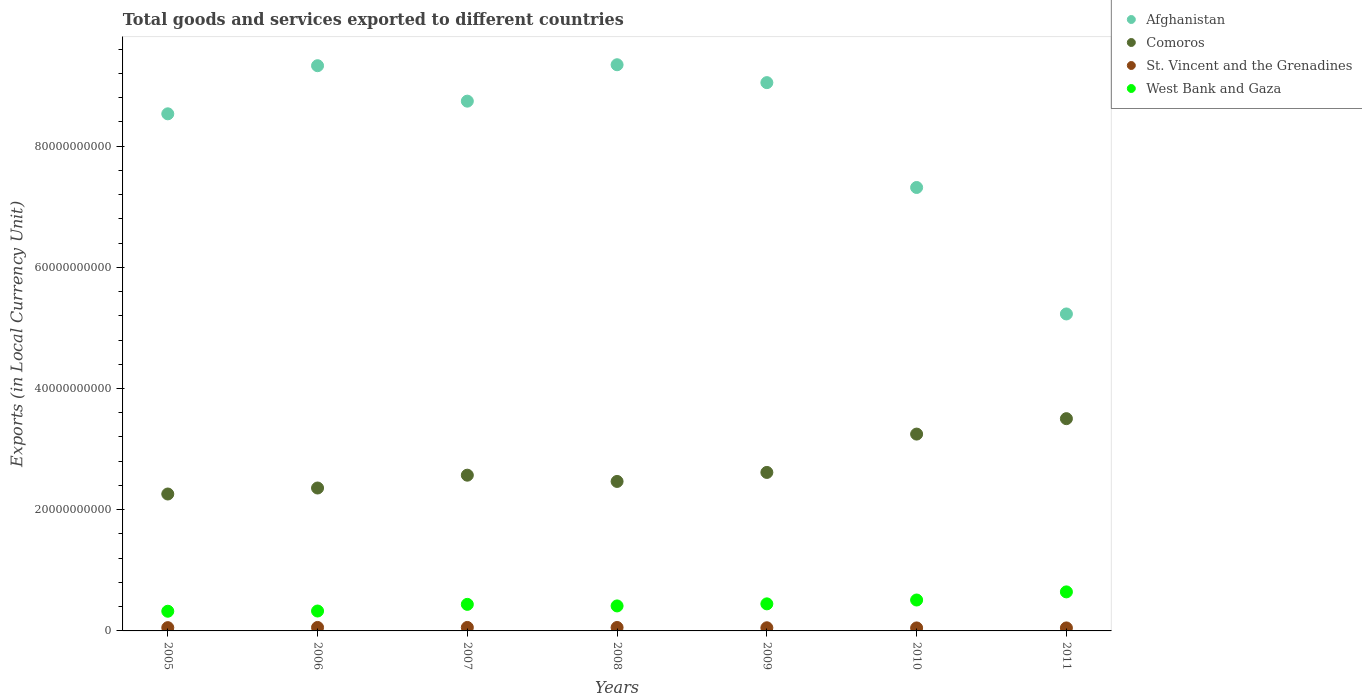What is the Amount of goods and services exports in West Bank and Gaza in 2005?
Provide a succinct answer. 3.25e+09. Across all years, what is the maximum Amount of goods and services exports in West Bank and Gaza?
Offer a terse response. 6.44e+09. Across all years, what is the minimum Amount of goods and services exports in West Bank and Gaza?
Your answer should be compact. 3.25e+09. In which year was the Amount of goods and services exports in Afghanistan maximum?
Offer a very short reply. 2008. In which year was the Amount of goods and services exports in Comoros minimum?
Your answer should be compact. 2005. What is the total Amount of goods and services exports in St. Vincent and the Grenadines in the graph?
Ensure brevity in your answer.  3.76e+09. What is the difference between the Amount of goods and services exports in West Bank and Gaza in 2009 and that in 2011?
Your response must be concise. -1.98e+09. What is the difference between the Amount of goods and services exports in Afghanistan in 2006 and the Amount of goods and services exports in St. Vincent and the Grenadines in 2007?
Make the answer very short. 9.27e+1. What is the average Amount of goods and services exports in Comoros per year?
Provide a succinct answer. 2.72e+1. In the year 2006, what is the difference between the Amount of goods and services exports in West Bank and Gaza and Amount of goods and services exports in St. Vincent and the Grenadines?
Make the answer very short. 2.71e+09. In how many years, is the Amount of goods and services exports in St. Vincent and the Grenadines greater than 48000000000 LCU?
Keep it short and to the point. 0. What is the ratio of the Amount of goods and services exports in West Bank and Gaza in 2006 to that in 2008?
Provide a succinct answer. 0.8. Is the Amount of goods and services exports in Comoros in 2006 less than that in 2011?
Offer a terse response. Yes. Is the difference between the Amount of goods and services exports in West Bank and Gaza in 2008 and 2010 greater than the difference between the Amount of goods and services exports in St. Vincent and the Grenadines in 2008 and 2010?
Your answer should be very brief. No. What is the difference between the highest and the second highest Amount of goods and services exports in St. Vincent and the Grenadines?
Offer a terse response. 6.09e+05. What is the difference between the highest and the lowest Amount of goods and services exports in Comoros?
Provide a succinct answer. 1.24e+1. Is it the case that in every year, the sum of the Amount of goods and services exports in Comoros and Amount of goods and services exports in Afghanistan  is greater than the Amount of goods and services exports in St. Vincent and the Grenadines?
Ensure brevity in your answer.  Yes. Does the Amount of goods and services exports in Comoros monotonically increase over the years?
Your answer should be very brief. No. Is the Amount of goods and services exports in St. Vincent and the Grenadines strictly less than the Amount of goods and services exports in West Bank and Gaza over the years?
Keep it short and to the point. Yes. How many dotlines are there?
Offer a very short reply. 4. How many years are there in the graph?
Provide a succinct answer. 7. What is the difference between two consecutive major ticks on the Y-axis?
Keep it short and to the point. 2.00e+1. Does the graph contain any zero values?
Offer a very short reply. No. Where does the legend appear in the graph?
Make the answer very short. Top right. How many legend labels are there?
Your answer should be compact. 4. What is the title of the graph?
Make the answer very short. Total goods and services exported to different countries. Does "Ethiopia" appear as one of the legend labels in the graph?
Keep it short and to the point. No. What is the label or title of the X-axis?
Ensure brevity in your answer.  Years. What is the label or title of the Y-axis?
Provide a succinct answer. Exports (in Local Currency Unit). What is the Exports (in Local Currency Unit) of Afghanistan in 2005?
Your answer should be compact. 8.53e+1. What is the Exports (in Local Currency Unit) of Comoros in 2005?
Keep it short and to the point. 2.26e+1. What is the Exports (in Local Currency Unit) in St. Vincent and the Grenadines in 2005?
Give a very brief answer. 5.41e+08. What is the Exports (in Local Currency Unit) of West Bank and Gaza in 2005?
Your response must be concise. 3.25e+09. What is the Exports (in Local Currency Unit) of Afghanistan in 2006?
Make the answer very short. 9.33e+1. What is the Exports (in Local Currency Unit) of Comoros in 2006?
Your answer should be very brief. 2.36e+1. What is the Exports (in Local Currency Unit) of St. Vincent and the Grenadines in 2006?
Offer a very short reply. 5.72e+08. What is the Exports (in Local Currency Unit) in West Bank and Gaza in 2006?
Your response must be concise. 3.28e+09. What is the Exports (in Local Currency Unit) in Afghanistan in 2007?
Give a very brief answer. 8.74e+1. What is the Exports (in Local Currency Unit) of Comoros in 2007?
Offer a terse response. 2.57e+1. What is the Exports (in Local Currency Unit) in St. Vincent and the Grenadines in 2007?
Provide a succinct answer. 5.73e+08. What is the Exports (in Local Currency Unit) of West Bank and Gaza in 2007?
Provide a succinct answer. 4.38e+09. What is the Exports (in Local Currency Unit) of Afghanistan in 2008?
Make the answer very short. 9.34e+1. What is the Exports (in Local Currency Unit) of Comoros in 2008?
Your answer should be very brief. 2.47e+1. What is the Exports (in Local Currency Unit) of St. Vincent and the Grenadines in 2008?
Make the answer very short. 5.67e+08. What is the Exports (in Local Currency Unit) of West Bank and Gaza in 2008?
Your answer should be very brief. 4.12e+09. What is the Exports (in Local Currency Unit) in Afghanistan in 2009?
Your answer should be compact. 9.05e+1. What is the Exports (in Local Currency Unit) of Comoros in 2009?
Keep it short and to the point. 2.62e+1. What is the Exports (in Local Currency Unit) in St. Vincent and the Grenadines in 2009?
Provide a short and direct response. 5.19e+08. What is the Exports (in Local Currency Unit) of West Bank and Gaza in 2009?
Offer a terse response. 4.47e+09. What is the Exports (in Local Currency Unit) of Afghanistan in 2010?
Provide a short and direct response. 7.32e+1. What is the Exports (in Local Currency Unit) in Comoros in 2010?
Keep it short and to the point. 3.25e+1. What is the Exports (in Local Currency Unit) in St. Vincent and the Grenadines in 2010?
Give a very brief answer. 4.95e+08. What is the Exports (in Local Currency Unit) of West Bank and Gaza in 2010?
Ensure brevity in your answer.  5.10e+09. What is the Exports (in Local Currency Unit) in Afghanistan in 2011?
Offer a terse response. 5.23e+1. What is the Exports (in Local Currency Unit) in Comoros in 2011?
Provide a succinct answer. 3.50e+1. What is the Exports (in Local Currency Unit) in St. Vincent and the Grenadines in 2011?
Offer a very short reply. 4.94e+08. What is the Exports (in Local Currency Unit) of West Bank and Gaza in 2011?
Provide a short and direct response. 6.44e+09. Across all years, what is the maximum Exports (in Local Currency Unit) of Afghanistan?
Make the answer very short. 9.34e+1. Across all years, what is the maximum Exports (in Local Currency Unit) of Comoros?
Ensure brevity in your answer.  3.50e+1. Across all years, what is the maximum Exports (in Local Currency Unit) of St. Vincent and the Grenadines?
Your answer should be very brief. 5.73e+08. Across all years, what is the maximum Exports (in Local Currency Unit) of West Bank and Gaza?
Keep it short and to the point. 6.44e+09. Across all years, what is the minimum Exports (in Local Currency Unit) in Afghanistan?
Your response must be concise. 5.23e+1. Across all years, what is the minimum Exports (in Local Currency Unit) in Comoros?
Your response must be concise. 2.26e+1. Across all years, what is the minimum Exports (in Local Currency Unit) of St. Vincent and the Grenadines?
Your answer should be very brief. 4.94e+08. Across all years, what is the minimum Exports (in Local Currency Unit) of West Bank and Gaza?
Make the answer very short. 3.25e+09. What is the total Exports (in Local Currency Unit) in Afghanistan in the graph?
Provide a succinct answer. 5.75e+11. What is the total Exports (in Local Currency Unit) of Comoros in the graph?
Make the answer very short. 1.90e+11. What is the total Exports (in Local Currency Unit) in St. Vincent and the Grenadines in the graph?
Offer a very short reply. 3.76e+09. What is the total Exports (in Local Currency Unit) of West Bank and Gaza in the graph?
Give a very brief answer. 3.10e+1. What is the difference between the Exports (in Local Currency Unit) of Afghanistan in 2005 and that in 2006?
Provide a short and direct response. -7.94e+09. What is the difference between the Exports (in Local Currency Unit) in Comoros in 2005 and that in 2006?
Offer a very short reply. -9.89e+08. What is the difference between the Exports (in Local Currency Unit) in St. Vincent and the Grenadines in 2005 and that in 2006?
Offer a terse response. -3.09e+07. What is the difference between the Exports (in Local Currency Unit) of West Bank and Gaza in 2005 and that in 2006?
Provide a short and direct response. -3.63e+07. What is the difference between the Exports (in Local Currency Unit) in Afghanistan in 2005 and that in 2007?
Your response must be concise. -2.09e+09. What is the difference between the Exports (in Local Currency Unit) of Comoros in 2005 and that in 2007?
Give a very brief answer. -3.11e+09. What is the difference between the Exports (in Local Currency Unit) of St. Vincent and the Grenadines in 2005 and that in 2007?
Keep it short and to the point. -3.15e+07. What is the difference between the Exports (in Local Currency Unit) in West Bank and Gaza in 2005 and that in 2007?
Make the answer very short. -1.13e+09. What is the difference between the Exports (in Local Currency Unit) of Afghanistan in 2005 and that in 2008?
Ensure brevity in your answer.  -8.10e+09. What is the difference between the Exports (in Local Currency Unit) of Comoros in 2005 and that in 2008?
Provide a short and direct response. -2.07e+09. What is the difference between the Exports (in Local Currency Unit) in St. Vincent and the Grenadines in 2005 and that in 2008?
Your answer should be very brief. -2.60e+07. What is the difference between the Exports (in Local Currency Unit) of West Bank and Gaza in 2005 and that in 2008?
Your response must be concise. -8.76e+08. What is the difference between the Exports (in Local Currency Unit) in Afghanistan in 2005 and that in 2009?
Make the answer very short. -5.15e+09. What is the difference between the Exports (in Local Currency Unit) of Comoros in 2005 and that in 2009?
Offer a very short reply. -3.56e+09. What is the difference between the Exports (in Local Currency Unit) in St. Vincent and the Grenadines in 2005 and that in 2009?
Offer a terse response. 2.22e+07. What is the difference between the Exports (in Local Currency Unit) of West Bank and Gaza in 2005 and that in 2009?
Provide a short and direct response. -1.22e+09. What is the difference between the Exports (in Local Currency Unit) in Afghanistan in 2005 and that in 2010?
Provide a short and direct response. 1.22e+1. What is the difference between the Exports (in Local Currency Unit) of Comoros in 2005 and that in 2010?
Your response must be concise. -9.89e+09. What is the difference between the Exports (in Local Currency Unit) of St. Vincent and the Grenadines in 2005 and that in 2010?
Keep it short and to the point. 4.69e+07. What is the difference between the Exports (in Local Currency Unit) of West Bank and Gaza in 2005 and that in 2010?
Your answer should be very brief. -1.85e+09. What is the difference between the Exports (in Local Currency Unit) of Afghanistan in 2005 and that in 2011?
Offer a very short reply. 3.30e+1. What is the difference between the Exports (in Local Currency Unit) in Comoros in 2005 and that in 2011?
Provide a short and direct response. -1.24e+1. What is the difference between the Exports (in Local Currency Unit) of St. Vincent and the Grenadines in 2005 and that in 2011?
Offer a very short reply. 4.79e+07. What is the difference between the Exports (in Local Currency Unit) in West Bank and Gaza in 2005 and that in 2011?
Make the answer very short. -3.19e+09. What is the difference between the Exports (in Local Currency Unit) in Afghanistan in 2006 and that in 2007?
Keep it short and to the point. 5.85e+09. What is the difference between the Exports (in Local Currency Unit) of Comoros in 2006 and that in 2007?
Provide a succinct answer. -2.12e+09. What is the difference between the Exports (in Local Currency Unit) of St. Vincent and the Grenadines in 2006 and that in 2007?
Provide a short and direct response. -6.09e+05. What is the difference between the Exports (in Local Currency Unit) of West Bank and Gaza in 2006 and that in 2007?
Make the answer very short. -1.10e+09. What is the difference between the Exports (in Local Currency Unit) in Afghanistan in 2006 and that in 2008?
Provide a succinct answer. -1.60e+08. What is the difference between the Exports (in Local Currency Unit) of Comoros in 2006 and that in 2008?
Your response must be concise. -1.08e+09. What is the difference between the Exports (in Local Currency Unit) of St. Vincent and the Grenadines in 2006 and that in 2008?
Provide a short and direct response. 4.93e+06. What is the difference between the Exports (in Local Currency Unit) in West Bank and Gaza in 2006 and that in 2008?
Your answer should be compact. -8.40e+08. What is the difference between the Exports (in Local Currency Unit) in Afghanistan in 2006 and that in 2009?
Provide a succinct answer. 2.79e+09. What is the difference between the Exports (in Local Currency Unit) of Comoros in 2006 and that in 2009?
Offer a very short reply. -2.57e+09. What is the difference between the Exports (in Local Currency Unit) in St. Vincent and the Grenadines in 2006 and that in 2009?
Give a very brief answer. 5.32e+07. What is the difference between the Exports (in Local Currency Unit) in West Bank and Gaza in 2006 and that in 2009?
Make the answer very short. -1.18e+09. What is the difference between the Exports (in Local Currency Unit) in Afghanistan in 2006 and that in 2010?
Provide a succinct answer. 2.01e+1. What is the difference between the Exports (in Local Currency Unit) in Comoros in 2006 and that in 2010?
Your answer should be very brief. -8.90e+09. What is the difference between the Exports (in Local Currency Unit) of St. Vincent and the Grenadines in 2006 and that in 2010?
Give a very brief answer. 7.78e+07. What is the difference between the Exports (in Local Currency Unit) of West Bank and Gaza in 2006 and that in 2010?
Provide a short and direct response. -1.82e+09. What is the difference between the Exports (in Local Currency Unit) of Afghanistan in 2006 and that in 2011?
Ensure brevity in your answer.  4.10e+1. What is the difference between the Exports (in Local Currency Unit) of Comoros in 2006 and that in 2011?
Offer a very short reply. -1.14e+1. What is the difference between the Exports (in Local Currency Unit) in St. Vincent and the Grenadines in 2006 and that in 2011?
Give a very brief answer. 7.88e+07. What is the difference between the Exports (in Local Currency Unit) of West Bank and Gaza in 2006 and that in 2011?
Provide a succinct answer. -3.16e+09. What is the difference between the Exports (in Local Currency Unit) in Afghanistan in 2007 and that in 2008?
Provide a succinct answer. -6.01e+09. What is the difference between the Exports (in Local Currency Unit) of Comoros in 2007 and that in 2008?
Provide a short and direct response. 1.03e+09. What is the difference between the Exports (in Local Currency Unit) of St. Vincent and the Grenadines in 2007 and that in 2008?
Your response must be concise. 5.54e+06. What is the difference between the Exports (in Local Currency Unit) of West Bank and Gaza in 2007 and that in 2008?
Provide a succinct answer. 2.58e+08. What is the difference between the Exports (in Local Currency Unit) of Afghanistan in 2007 and that in 2009?
Your response must be concise. -3.06e+09. What is the difference between the Exports (in Local Currency Unit) in Comoros in 2007 and that in 2009?
Provide a succinct answer. -4.55e+08. What is the difference between the Exports (in Local Currency Unit) of St. Vincent and the Grenadines in 2007 and that in 2009?
Ensure brevity in your answer.  5.38e+07. What is the difference between the Exports (in Local Currency Unit) in West Bank and Gaza in 2007 and that in 2009?
Keep it short and to the point. -8.27e+07. What is the difference between the Exports (in Local Currency Unit) in Afghanistan in 2007 and that in 2010?
Offer a very short reply. 1.42e+1. What is the difference between the Exports (in Local Currency Unit) of Comoros in 2007 and that in 2010?
Your answer should be very brief. -6.78e+09. What is the difference between the Exports (in Local Currency Unit) of St. Vincent and the Grenadines in 2007 and that in 2010?
Provide a succinct answer. 7.84e+07. What is the difference between the Exports (in Local Currency Unit) of West Bank and Gaza in 2007 and that in 2010?
Keep it short and to the point. -7.18e+08. What is the difference between the Exports (in Local Currency Unit) in Afghanistan in 2007 and that in 2011?
Offer a terse response. 3.51e+1. What is the difference between the Exports (in Local Currency Unit) in Comoros in 2007 and that in 2011?
Ensure brevity in your answer.  -9.33e+09. What is the difference between the Exports (in Local Currency Unit) in St. Vincent and the Grenadines in 2007 and that in 2011?
Your answer should be compact. 7.95e+07. What is the difference between the Exports (in Local Currency Unit) of West Bank and Gaza in 2007 and that in 2011?
Provide a short and direct response. -2.06e+09. What is the difference between the Exports (in Local Currency Unit) of Afghanistan in 2008 and that in 2009?
Your answer should be compact. 2.95e+09. What is the difference between the Exports (in Local Currency Unit) of Comoros in 2008 and that in 2009?
Offer a very short reply. -1.49e+09. What is the difference between the Exports (in Local Currency Unit) in St. Vincent and the Grenadines in 2008 and that in 2009?
Offer a very short reply. 4.82e+07. What is the difference between the Exports (in Local Currency Unit) of West Bank and Gaza in 2008 and that in 2009?
Ensure brevity in your answer.  -3.41e+08. What is the difference between the Exports (in Local Currency Unit) of Afghanistan in 2008 and that in 2010?
Provide a succinct answer. 2.03e+1. What is the difference between the Exports (in Local Currency Unit) in Comoros in 2008 and that in 2010?
Give a very brief answer. -7.81e+09. What is the difference between the Exports (in Local Currency Unit) of St. Vincent and the Grenadines in 2008 and that in 2010?
Give a very brief answer. 7.29e+07. What is the difference between the Exports (in Local Currency Unit) of West Bank and Gaza in 2008 and that in 2010?
Keep it short and to the point. -9.76e+08. What is the difference between the Exports (in Local Currency Unit) of Afghanistan in 2008 and that in 2011?
Keep it short and to the point. 4.11e+1. What is the difference between the Exports (in Local Currency Unit) of Comoros in 2008 and that in 2011?
Offer a terse response. -1.04e+1. What is the difference between the Exports (in Local Currency Unit) in St. Vincent and the Grenadines in 2008 and that in 2011?
Provide a succinct answer. 7.39e+07. What is the difference between the Exports (in Local Currency Unit) of West Bank and Gaza in 2008 and that in 2011?
Offer a very short reply. -2.32e+09. What is the difference between the Exports (in Local Currency Unit) in Afghanistan in 2009 and that in 2010?
Keep it short and to the point. 1.73e+1. What is the difference between the Exports (in Local Currency Unit) of Comoros in 2009 and that in 2010?
Your answer should be compact. -6.33e+09. What is the difference between the Exports (in Local Currency Unit) in St. Vincent and the Grenadines in 2009 and that in 2010?
Offer a very short reply. 2.46e+07. What is the difference between the Exports (in Local Currency Unit) in West Bank and Gaza in 2009 and that in 2010?
Provide a succinct answer. -6.35e+08. What is the difference between the Exports (in Local Currency Unit) in Afghanistan in 2009 and that in 2011?
Give a very brief answer. 3.82e+1. What is the difference between the Exports (in Local Currency Unit) in Comoros in 2009 and that in 2011?
Provide a short and direct response. -8.87e+09. What is the difference between the Exports (in Local Currency Unit) in St. Vincent and the Grenadines in 2009 and that in 2011?
Offer a very short reply. 2.57e+07. What is the difference between the Exports (in Local Currency Unit) of West Bank and Gaza in 2009 and that in 2011?
Your response must be concise. -1.98e+09. What is the difference between the Exports (in Local Currency Unit) of Afghanistan in 2010 and that in 2011?
Make the answer very short. 2.09e+1. What is the difference between the Exports (in Local Currency Unit) of Comoros in 2010 and that in 2011?
Ensure brevity in your answer.  -2.54e+09. What is the difference between the Exports (in Local Currency Unit) in St. Vincent and the Grenadines in 2010 and that in 2011?
Make the answer very short. 1.06e+06. What is the difference between the Exports (in Local Currency Unit) of West Bank and Gaza in 2010 and that in 2011?
Your response must be concise. -1.34e+09. What is the difference between the Exports (in Local Currency Unit) in Afghanistan in 2005 and the Exports (in Local Currency Unit) in Comoros in 2006?
Offer a very short reply. 6.17e+1. What is the difference between the Exports (in Local Currency Unit) in Afghanistan in 2005 and the Exports (in Local Currency Unit) in St. Vincent and the Grenadines in 2006?
Provide a short and direct response. 8.47e+1. What is the difference between the Exports (in Local Currency Unit) in Afghanistan in 2005 and the Exports (in Local Currency Unit) in West Bank and Gaza in 2006?
Offer a terse response. 8.20e+1. What is the difference between the Exports (in Local Currency Unit) in Comoros in 2005 and the Exports (in Local Currency Unit) in St. Vincent and the Grenadines in 2006?
Your answer should be compact. 2.20e+1. What is the difference between the Exports (in Local Currency Unit) of Comoros in 2005 and the Exports (in Local Currency Unit) of West Bank and Gaza in 2006?
Offer a terse response. 1.93e+1. What is the difference between the Exports (in Local Currency Unit) of St. Vincent and the Grenadines in 2005 and the Exports (in Local Currency Unit) of West Bank and Gaza in 2006?
Make the answer very short. -2.74e+09. What is the difference between the Exports (in Local Currency Unit) in Afghanistan in 2005 and the Exports (in Local Currency Unit) in Comoros in 2007?
Your answer should be compact. 5.96e+1. What is the difference between the Exports (in Local Currency Unit) of Afghanistan in 2005 and the Exports (in Local Currency Unit) of St. Vincent and the Grenadines in 2007?
Your answer should be very brief. 8.47e+1. What is the difference between the Exports (in Local Currency Unit) of Afghanistan in 2005 and the Exports (in Local Currency Unit) of West Bank and Gaza in 2007?
Ensure brevity in your answer.  8.09e+1. What is the difference between the Exports (in Local Currency Unit) of Comoros in 2005 and the Exports (in Local Currency Unit) of St. Vincent and the Grenadines in 2007?
Your response must be concise. 2.20e+1. What is the difference between the Exports (in Local Currency Unit) in Comoros in 2005 and the Exports (in Local Currency Unit) in West Bank and Gaza in 2007?
Your answer should be very brief. 1.82e+1. What is the difference between the Exports (in Local Currency Unit) in St. Vincent and the Grenadines in 2005 and the Exports (in Local Currency Unit) in West Bank and Gaza in 2007?
Provide a succinct answer. -3.84e+09. What is the difference between the Exports (in Local Currency Unit) of Afghanistan in 2005 and the Exports (in Local Currency Unit) of Comoros in 2008?
Ensure brevity in your answer.  6.07e+1. What is the difference between the Exports (in Local Currency Unit) in Afghanistan in 2005 and the Exports (in Local Currency Unit) in St. Vincent and the Grenadines in 2008?
Your answer should be very brief. 8.48e+1. What is the difference between the Exports (in Local Currency Unit) of Afghanistan in 2005 and the Exports (in Local Currency Unit) of West Bank and Gaza in 2008?
Your answer should be very brief. 8.12e+1. What is the difference between the Exports (in Local Currency Unit) of Comoros in 2005 and the Exports (in Local Currency Unit) of St. Vincent and the Grenadines in 2008?
Ensure brevity in your answer.  2.20e+1. What is the difference between the Exports (in Local Currency Unit) of Comoros in 2005 and the Exports (in Local Currency Unit) of West Bank and Gaza in 2008?
Make the answer very short. 1.85e+1. What is the difference between the Exports (in Local Currency Unit) in St. Vincent and the Grenadines in 2005 and the Exports (in Local Currency Unit) in West Bank and Gaza in 2008?
Offer a terse response. -3.58e+09. What is the difference between the Exports (in Local Currency Unit) of Afghanistan in 2005 and the Exports (in Local Currency Unit) of Comoros in 2009?
Ensure brevity in your answer.  5.92e+1. What is the difference between the Exports (in Local Currency Unit) of Afghanistan in 2005 and the Exports (in Local Currency Unit) of St. Vincent and the Grenadines in 2009?
Give a very brief answer. 8.48e+1. What is the difference between the Exports (in Local Currency Unit) of Afghanistan in 2005 and the Exports (in Local Currency Unit) of West Bank and Gaza in 2009?
Keep it short and to the point. 8.09e+1. What is the difference between the Exports (in Local Currency Unit) of Comoros in 2005 and the Exports (in Local Currency Unit) of St. Vincent and the Grenadines in 2009?
Your answer should be compact. 2.21e+1. What is the difference between the Exports (in Local Currency Unit) in Comoros in 2005 and the Exports (in Local Currency Unit) in West Bank and Gaza in 2009?
Ensure brevity in your answer.  1.81e+1. What is the difference between the Exports (in Local Currency Unit) of St. Vincent and the Grenadines in 2005 and the Exports (in Local Currency Unit) of West Bank and Gaza in 2009?
Keep it short and to the point. -3.92e+09. What is the difference between the Exports (in Local Currency Unit) in Afghanistan in 2005 and the Exports (in Local Currency Unit) in Comoros in 2010?
Ensure brevity in your answer.  5.28e+1. What is the difference between the Exports (in Local Currency Unit) of Afghanistan in 2005 and the Exports (in Local Currency Unit) of St. Vincent and the Grenadines in 2010?
Your answer should be very brief. 8.48e+1. What is the difference between the Exports (in Local Currency Unit) in Afghanistan in 2005 and the Exports (in Local Currency Unit) in West Bank and Gaza in 2010?
Your answer should be compact. 8.02e+1. What is the difference between the Exports (in Local Currency Unit) in Comoros in 2005 and the Exports (in Local Currency Unit) in St. Vincent and the Grenadines in 2010?
Your answer should be very brief. 2.21e+1. What is the difference between the Exports (in Local Currency Unit) in Comoros in 2005 and the Exports (in Local Currency Unit) in West Bank and Gaza in 2010?
Make the answer very short. 1.75e+1. What is the difference between the Exports (in Local Currency Unit) of St. Vincent and the Grenadines in 2005 and the Exports (in Local Currency Unit) of West Bank and Gaza in 2010?
Give a very brief answer. -4.56e+09. What is the difference between the Exports (in Local Currency Unit) of Afghanistan in 2005 and the Exports (in Local Currency Unit) of Comoros in 2011?
Your response must be concise. 5.03e+1. What is the difference between the Exports (in Local Currency Unit) of Afghanistan in 2005 and the Exports (in Local Currency Unit) of St. Vincent and the Grenadines in 2011?
Ensure brevity in your answer.  8.48e+1. What is the difference between the Exports (in Local Currency Unit) of Afghanistan in 2005 and the Exports (in Local Currency Unit) of West Bank and Gaza in 2011?
Offer a terse response. 7.89e+1. What is the difference between the Exports (in Local Currency Unit) of Comoros in 2005 and the Exports (in Local Currency Unit) of St. Vincent and the Grenadines in 2011?
Keep it short and to the point. 2.21e+1. What is the difference between the Exports (in Local Currency Unit) of Comoros in 2005 and the Exports (in Local Currency Unit) of West Bank and Gaza in 2011?
Your answer should be very brief. 1.61e+1. What is the difference between the Exports (in Local Currency Unit) of St. Vincent and the Grenadines in 2005 and the Exports (in Local Currency Unit) of West Bank and Gaza in 2011?
Your answer should be compact. -5.90e+09. What is the difference between the Exports (in Local Currency Unit) in Afghanistan in 2006 and the Exports (in Local Currency Unit) in Comoros in 2007?
Your answer should be very brief. 6.76e+1. What is the difference between the Exports (in Local Currency Unit) of Afghanistan in 2006 and the Exports (in Local Currency Unit) of St. Vincent and the Grenadines in 2007?
Your response must be concise. 9.27e+1. What is the difference between the Exports (in Local Currency Unit) in Afghanistan in 2006 and the Exports (in Local Currency Unit) in West Bank and Gaza in 2007?
Provide a short and direct response. 8.89e+1. What is the difference between the Exports (in Local Currency Unit) in Comoros in 2006 and the Exports (in Local Currency Unit) in St. Vincent and the Grenadines in 2007?
Offer a very short reply. 2.30e+1. What is the difference between the Exports (in Local Currency Unit) of Comoros in 2006 and the Exports (in Local Currency Unit) of West Bank and Gaza in 2007?
Provide a succinct answer. 1.92e+1. What is the difference between the Exports (in Local Currency Unit) of St. Vincent and the Grenadines in 2006 and the Exports (in Local Currency Unit) of West Bank and Gaza in 2007?
Keep it short and to the point. -3.81e+09. What is the difference between the Exports (in Local Currency Unit) in Afghanistan in 2006 and the Exports (in Local Currency Unit) in Comoros in 2008?
Keep it short and to the point. 6.86e+1. What is the difference between the Exports (in Local Currency Unit) of Afghanistan in 2006 and the Exports (in Local Currency Unit) of St. Vincent and the Grenadines in 2008?
Make the answer very short. 9.27e+1. What is the difference between the Exports (in Local Currency Unit) in Afghanistan in 2006 and the Exports (in Local Currency Unit) in West Bank and Gaza in 2008?
Offer a terse response. 8.91e+1. What is the difference between the Exports (in Local Currency Unit) of Comoros in 2006 and the Exports (in Local Currency Unit) of St. Vincent and the Grenadines in 2008?
Your answer should be compact. 2.30e+1. What is the difference between the Exports (in Local Currency Unit) in Comoros in 2006 and the Exports (in Local Currency Unit) in West Bank and Gaza in 2008?
Offer a terse response. 1.95e+1. What is the difference between the Exports (in Local Currency Unit) in St. Vincent and the Grenadines in 2006 and the Exports (in Local Currency Unit) in West Bank and Gaza in 2008?
Offer a terse response. -3.55e+09. What is the difference between the Exports (in Local Currency Unit) of Afghanistan in 2006 and the Exports (in Local Currency Unit) of Comoros in 2009?
Offer a terse response. 6.71e+1. What is the difference between the Exports (in Local Currency Unit) in Afghanistan in 2006 and the Exports (in Local Currency Unit) in St. Vincent and the Grenadines in 2009?
Provide a succinct answer. 9.27e+1. What is the difference between the Exports (in Local Currency Unit) in Afghanistan in 2006 and the Exports (in Local Currency Unit) in West Bank and Gaza in 2009?
Offer a terse response. 8.88e+1. What is the difference between the Exports (in Local Currency Unit) of Comoros in 2006 and the Exports (in Local Currency Unit) of St. Vincent and the Grenadines in 2009?
Ensure brevity in your answer.  2.31e+1. What is the difference between the Exports (in Local Currency Unit) in Comoros in 2006 and the Exports (in Local Currency Unit) in West Bank and Gaza in 2009?
Your answer should be very brief. 1.91e+1. What is the difference between the Exports (in Local Currency Unit) in St. Vincent and the Grenadines in 2006 and the Exports (in Local Currency Unit) in West Bank and Gaza in 2009?
Ensure brevity in your answer.  -3.89e+09. What is the difference between the Exports (in Local Currency Unit) of Afghanistan in 2006 and the Exports (in Local Currency Unit) of Comoros in 2010?
Offer a terse response. 6.08e+1. What is the difference between the Exports (in Local Currency Unit) of Afghanistan in 2006 and the Exports (in Local Currency Unit) of St. Vincent and the Grenadines in 2010?
Provide a succinct answer. 9.28e+1. What is the difference between the Exports (in Local Currency Unit) in Afghanistan in 2006 and the Exports (in Local Currency Unit) in West Bank and Gaza in 2010?
Provide a short and direct response. 8.82e+1. What is the difference between the Exports (in Local Currency Unit) of Comoros in 2006 and the Exports (in Local Currency Unit) of St. Vincent and the Grenadines in 2010?
Offer a very short reply. 2.31e+1. What is the difference between the Exports (in Local Currency Unit) of Comoros in 2006 and the Exports (in Local Currency Unit) of West Bank and Gaza in 2010?
Your answer should be compact. 1.85e+1. What is the difference between the Exports (in Local Currency Unit) of St. Vincent and the Grenadines in 2006 and the Exports (in Local Currency Unit) of West Bank and Gaza in 2010?
Your answer should be very brief. -4.53e+09. What is the difference between the Exports (in Local Currency Unit) in Afghanistan in 2006 and the Exports (in Local Currency Unit) in Comoros in 2011?
Ensure brevity in your answer.  5.82e+1. What is the difference between the Exports (in Local Currency Unit) of Afghanistan in 2006 and the Exports (in Local Currency Unit) of St. Vincent and the Grenadines in 2011?
Provide a succinct answer. 9.28e+1. What is the difference between the Exports (in Local Currency Unit) of Afghanistan in 2006 and the Exports (in Local Currency Unit) of West Bank and Gaza in 2011?
Your answer should be compact. 8.68e+1. What is the difference between the Exports (in Local Currency Unit) in Comoros in 2006 and the Exports (in Local Currency Unit) in St. Vincent and the Grenadines in 2011?
Offer a terse response. 2.31e+1. What is the difference between the Exports (in Local Currency Unit) in Comoros in 2006 and the Exports (in Local Currency Unit) in West Bank and Gaza in 2011?
Your answer should be compact. 1.71e+1. What is the difference between the Exports (in Local Currency Unit) in St. Vincent and the Grenadines in 2006 and the Exports (in Local Currency Unit) in West Bank and Gaza in 2011?
Offer a terse response. -5.87e+09. What is the difference between the Exports (in Local Currency Unit) in Afghanistan in 2007 and the Exports (in Local Currency Unit) in Comoros in 2008?
Give a very brief answer. 6.27e+1. What is the difference between the Exports (in Local Currency Unit) of Afghanistan in 2007 and the Exports (in Local Currency Unit) of St. Vincent and the Grenadines in 2008?
Offer a terse response. 8.68e+1. What is the difference between the Exports (in Local Currency Unit) in Afghanistan in 2007 and the Exports (in Local Currency Unit) in West Bank and Gaza in 2008?
Your response must be concise. 8.33e+1. What is the difference between the Exports (in Local Currency Unit) of Comoros in 2007 and the Exports (in Local Currency Unit) of St. Vincent and the Grenadines in 2008?
Offer a terse response. 2.51e+1. What is the difference between the Exports (in Local Currency Unit) in Comoros in 2007 and the Exports (in Local Currency Unit) in West Bank and Gaza in 2008?
Your answer should be compact. 2.16e+1. What is the difference between the Exports (in Local Currency Unit) of St. Vincent and the Grenadines in 2007 and the Exports (in Local Currency Unit) of West Bank and Gaza in 2008?
Offer a terse response. -3.55e+09. What is the difference between the Exports (in Local Currency Unit) of Afghanistan in 2007 and the Exports (in Local Currency Unit) of Comoros in 2009?
Your answer should be compact. 6.13e+1. What is the difference between the Exports (in Local Currency Unit) in Afghanistan in 2007 and the Exports (in Local Currency Unit) in St. Vincent and the Grenadines in 2009?
Your answer should be very brief. 8.69e+1. What is the difference between the Exports (in Local Currency Unit) of Afghanistan in 2007 and the Exports (in Local Currency Unit) of West Bank and Gaza in 2009?
Offer a terse response. 8.29e+1. What is the difference between the Exports (in Local Currency Unit) in Comoros in 2007 and the Exports (in Local Currency Unit) in St. Vincent and the Grenadines in 2009?
Offer a very short reply. 2.52e+1. What is the difference between the Exports (in Local Currency Unit) in Comoros in 2007 and the Exports (in Local Currency Unit) in West Bank and Gaza in 2009?
Keep it short and to the point. 2.12e+1. What is the difference between the Exports (in Local Currency Unit) in St. Vincent and the Grenadines in 2007 and the Exports (in Local Currency Unit) in West Bank and Gaza in 2009?
Provide a succinct answer. -3.89e+09. What is the difference between the Exports (in Local Currency Unit) in Afghanistan in 2007 and the Exports (in Local Currency Unit) in Comoros in 2010?
Your answer should be compact. 5.49e+1. What is the difference between the Exports (in Local Currency Unit) of Afghanistan in 2007 and the Exports (in Local Currency Unit) of St. Vincent and the Grenadines in 2010?
Make the answer very short. 8.69e+1. What is the difference between the Exports (in Local Currency Unit) in Afghanistan in 2007 and the Exports (in Local Currency Unit) in West Bank and Gaza in 2010?
Make the answer very short. 8.23e+1. What is the difference between the Exports (in Local Currency Unit) of Comoros in 2007 and the Exports (in Local Currency Unit) of St. Vincent and the Grenadines in 2010?
Make the answer very short. 2.52e+1. What is the difference between the Exports (in Local Currency Unit) in Comoros in 2007 and the Exports (in Local Currency Unit) in West Bank and Gaza in 2010?
Offer a very short reply. 2.06e+1. What is the difference between the Exports (in Local Currency Unit) of St. Vincent and the Grenadines in 2007 and the Exports (in Local Currency Unit) of West Bank and Gaza in 2010?
Make the answer very short. -4.53e+09. What is the difference between the Exports (in Local Currency Unit) of Afghanistan in 2007 and the Exports (in Local Currency Unit) of Comoros in 2011?
Make the answer very short. 5.24e+1. What is the difference between the Exports (in Local Currency Unit) in Afghanistan in 2007 and the Exports (in Local Currency Unit) in St. Vincent and the Grenadines in 2011?
Make the answer very short. 8.69e+1. What is the difference between the Exports (in Local Currency Unit) of Afghanistan in 2007 and the Exports (in Local Currency Unit) of West Bank and Gaza in 2011?
Your response must be concise. 8.10e+1. What is the difference between the Exports (in Local Currency Unit) of Comoros in 2007 and the Exports (in Local Currency Unit) of St. Vincent and the Grenadines in 2011?
Give a very brief answer. 2.52e+1. What is the difference between the Exports (in Local Currency Unit) in Comoros in 2007 and the Exports (in Local Currency Unit) in West Bank and Gaza in 2011?
Provide a succinct answer. 1.93e+1. What is the difference between the Exports (in Local Currency Unit) in St. Vincent and the Grenadines in 2007 and the Exports (in Local Currency Unit) in West Bank and Gaza in 2011?
Your answer should be very brief. -5.87e+09. What is the difference between the Exports (in Local Currency Unit) of Afghanistan in 2008 and the Exports (in Local Currency Unit) of Comoros in 2009?
Provide a succinct answer. 6.73e+1. What is the difference between the Exports (in Local Currency Unit) in Afghanistan in 2008 and the Exports (in Local Currency Unit) in St. Vincent and the Grenadines in 2009?
Ensure brevity in your answer.  9.29e+1. What is the difference between the Exports (in Local Currency Unit) of Afghanistan in 2008 and the Exports (in Local Currency Unit) of West Bank and Gaza in 2009?
Ensure brevity in your answer.  8.90e+1. What is the difference between the Exports (in Local Currency Unit) of Comoros in 2008 and the Exports (in Local Currency Unit) of St. Vincent and the Grenadines in 2009?
Provide a succinct answer. 2.41e+1. What is the difference between the Exports (in Local Currency Unit) of Comoros in 2008 and the Exports (in Local Currency Unit) of West Bank and Gaza in 2009?
Make the answer very short. 2.02e+1. What is the difference between the Exports (in Local Currency Unit) in St. Vincent and the Grenadines in 2008 and the Exports (in Local Currency Unit) in West Bank and Gaza in 2009?
Make the answer very short. -3.90e+09. What is the difference between the Exports (in Local Currency Unit) of Afghanistan in 2008 and the Exports (in Local Currency Unit) of Comoros in 2010?
Keep it short and to the point. 6.09e+1. What is the difference between the Exports (in Local Currency Unit) of Afghanistan in 2008 and the Exports (in Local Currency Unit) of St. Vincent and the Grenadines in 2010?
Your answer should be compact. 9.29e+1. What is the difference between the Exports (in Local Currency Unit) in Afghanistan in 2008 and the Exports (in Local Currency Unit) in West Bank and Gaza in 2010?
Offer a very short reply. 8.83e+1. What is the difference between the Exports (in Local Currency Unit) in Comoros in 2008 and the Exports (in Local Currency Unit) in St. Vincent and the Grenadines in 2010?
Your answer should be very brief. 2.42e+1. What is the difference between the Exports (in Local Currency Unit) of Comoros in 2008 and the Exports (in Local Currency Unit) of West Bank and Gaza in 2010?
Provide a short and direct response. 1.96e+1. What is the difference between the Exports (in Local Currency Unit) of St. Vincent and the Grenadines in 2008 and the Exports (in Local Currency Unit) of West Bank and Gaza in 2010?
Provide a short and direct response. -4.53e+09. What is the difference between the Exports (in Local Currency Unit) in Afghanistan in 2008 and the Exports (in Local Currency Unit) in Comoros in 2011?
Provide a succinct answer. 5.84e+1. What is the difference between the Exports (in Local Currency Unit) of Afghanistan in 2008 and the Exports (in Local Currency Unit) of St. Vincent and the Grenadines in 2011?
Your answer should be very brief. 9.29e+1. What is the difference between the Exports (in Local Currency Unit) in Afghanistan in 2008 and the Exports (in Local Currency Unit) in West Bank and Gaza in 2011?
Provide a short and direct response. 8.70e+1. What is the difference between the Exports (in Local Currency Unit) of Comoros in 2008 and the Exports (in Local Currency Unit) of St. Vincent and the Grenadines in 2011?
Offer a terse response. 2.42e+1. What is the difference between the Exports (in Local Currency Unit) in Comoros in 2008 and the Exports (in Local Currency Unit) in West Bank and Gaza in 2011?
Give a very brief answer. 1.82e+1. What is the difference between the Exports (in Local Currency Unit) in St. Vincent and the Grenadines in 2008 and the Exports (in Local Currency Unit) in West Bank and Gaza in 2011?
Make the answer very short. -5.87e+09. What is the difference between the Exports (in Local Currency Unit) in Afghanistan in 2009 and the Exports (in Local Currency Unit) in Comoros in 2010?
Provide a succinct answer. 5.80e+1. What is the difference between the Exports (in Local Currency Unit) of Afghanistan in 2009 and the Exports (in Local Currency Unit) of St. Vincent and the Grenadines in 2010?
Your answer should be very brief. 9.00e+1. What is the difference between the Exports (in Local Currency Unit) of Afghanistan in 2009 and the Exports (in Local Currency Unit) of West Bank and Gaza in 2010?
Keep it short and to the point. 8.54e+1. What is the difference between the Exports (in Local Currency Unit) of Comoros in 2009 and the Exports (in Local Currency Unit) of St. Vincent and the Grenadines in 2010?
Offer a very short reply. 2.57e+1. What is the difference between the Exports (in Local Currency Unit) in Comoros in 2009 and the Exports (in Local Currency Unit) in West Bank and Gaza in 2010?
Make the answer very short. 2.11e+1. What is the difference between the Exports (in Local Currency Unit) in St. Vincent and the Grenadines in 2009 and the Exports (in Local Currency Unit) in West Bank and Gaza in 2010?
Your answer should be compact. -4.58e+09. What is the difference between the Exports (in Local Currency Unit) of Afghanistan in 2009 and the Exports (in Local Currency Unit) of Comoros in 2011?
Your answer should be very brief. 5.54e+1. What is the difference between the Exports (in Local Currency Unit) of Afghanistan in 2009 and the Exports (in Local Currency Unit) of St. Vincent and the Grenadines in 2011?
Provide a short and direct response. 9.00e+1. What is the difference between the Exports (in Local Currency Unit) of Afghanistan in 2009 and the Exports (in Local Currency Unit) of West Bank and Gaza in 2011?
Offer a very short reply. 8.40e+1. What is the difference between the Exports (in Local Currency Unit) of Comoros in 2009 and the Exports (in Local Currency Unit) of St. Vincent and the Grenadines in 2011?
Provide a short and direct response. 2.57e+1. What is the difference between the Exports (in Local Currency Unit) in Comoros in 2009 and the Exports (in Local Currency Unit) in West Bank and Gaza in 2011?
Make the answer very short. 1.97e+1. What is the difference between the Exports (in Local Currency Unit) of St. Vincent and the Grenadines in 2009 and the Exports (in Local Currency Unit) of West Bank and Gaza in 2011?
Ensure brevity in your answer.  -5.92e+09. What is the difference between the Exports (in Local Currency Unit) in Afghanistan in 2010 and the Exports (in Local Currency Unit) in Comoros in 2011?
Offer a very short reply. 3.81e+1. What is the difference between the Exports (in Local Currency Unit) of Afghanistan in 2010 and the Exports (in Local Currency Unit) of St. Vincent and the Grenadines in 2011?
Give a very brief answer. 7.27e+1. What is the difference between the Exports (in Local Currency Unit) of Afghanistan in 2010 and the Exports (in Local Currency Unit) of West Bank and Gaza in 2011?
Provide a short and direct response. 6.67e+1. What is the difference between the Exports (in Local Currency Unit) in Comoros in 2010 and the Exports (in Local Currency Unit) in St. Vincent and the Grenadines in 2011?
Your response must be concise. 3.20e+1. What is the difference between the Exports (in Local Currency Unit) of Comoros in 2010 and the Exports (in Local Currency Unit) of West Bank and Gaza in 2011?
Provide a short and direct response. 2.60e+1. What is the difference between the Exports (in Local Currency Unit) of St. Vincent and the Grenadines in 2010 and the Exports (in Local Currency Unit) of West Bank and Gaza in 2011?
Ensure brevity in your answer.  -5.95e+09. What is the average Exports (in Local Currency Unit) in Afghanistan per year?
Ensure brevity in your answer.  8.22e+1. What is the average Exports (in Local Currency Unit) of Comoros per year?
Your answer should be compact. 2.72e+1. What is the average Exports (in Local Currency Unit) in St. Vincent and the Grenadines per year?
Your answer should be very brief. 5.37e+08. What is the average Exports (in Local Currency Unit) of West Bank and Gaza per year?
Make the answer very short. 4.44e+09. In the year 2005, what is the difference between the Exports (in Local Currency Unit) of Afghanistan and Exports (in Local Currency Unit) of Comoros?
Make the answer very short. 6.27e+1. In the year 2005, what is the difference between the Exports (in Local Currency Unit) of Afghanistan and Exports (in Local Currency Unit) of St. Vincent and the Grenadines?
Your answer should be very brief. 8.48e+1. In the year 2005, what is the difference between the Exports (in Local Currency Unit) of Afghanistan and Exports (in Local Currency Unit) of West Bank and Gaza?
Your answer should be compact. 8.21e+1. In the year 2005, what is the difference between the Exports (in Local Currency Unit) in Comoros and Exports (in Local Currency Unit) in St. Vincent and the Grenadines?
Your answer should be compact. 2.20e+1. In the year 2005, what is the difference between the Exports (in Local Currency Unit) of Comoros and Exports (in Local Currency Unit) of West Bank and Gaza?
Offer a terse response. 1.93e+1. In the year 2005, what is the difference between the Exports (in Local Currency Unit) in St. Vincent and the Grenadines and Exports (in Local Currency Unit) in West Bank and Gaza?
Keep it short and to the point. -2.71e+09. In the year 2006, what is the difference between the Exports (in Local Currency Unit) of Afghanistan and Exports (in Local Currency Unit) of Comoros?
Provide a succinct answer. 6.97e+1. In the year 2006, what is the difference between the Exports (in Local Currency Unit) in Afghanistan and Exports (in Local Currency Unit) in St. Vincent and the Grenadines?
Ensure brevity in your answer.  9.27e+1. In the year 2006, what is the difference between the Exports (in Local Currency Unit) of Afghanistan and Exports (in Local Currency Unit) of West Bank and Gaza?
Your answer should be compact. 9.00e+1. In the year 2006, what is the difference between the Exports (in Local Currency Unit) of Comoros and Exports (in Local Currency Unit) of St. Vincent and the Grenadines?
Keep it short and to the point. 2.30e+1. In the year 2006, what is the difference between the Exports (in Local Currency Unit) of Comoros and Exports (in Local Currency Unit) of West Bank and Gaza?
Provide a succinct answer. 2.03e+1. In the year 2006, what is the difference between the Exports (in Local Currency Unit) of St. Vincent and the Grenadines and Exports (in Local Currency Unit) of West Bank and Gaza?
Offer a very short reply. -2.71e+09. In the year 2007, what is the difference between the Exports (in Local Currency Unit) in Afghanistan and Exports (in Local Currency Unit) in Comoros?
Provide a short and direct response. 6.17e+1. In the year 2007, what is the difference between the Exports (in Local Currency Unit) in Afghanistan and Exports (in Local Currency Unit) in St. Vincent and the Grenadines?
Your answer should be very brief. 8.68e+1. In the year 2007, what is the difference between the Exports (in Local Currency Unit) in Afghanistan and Exports (in Local Currency Unit) in West Bank and Gaza?
Ensure brevity in your answer.  8.30e+1. In the year 2007, what is the difference between the Exports (in Local Currency Unit) in Comoros and Exports (in Local Currency Unit) in St. Vincent and the Grenadines?
Your answer should be compact. 2.51e+1. In the year 2007, what is the difference between the Exports (in Local Currency Unit) in Comoros and Exports (in Local Currency Unit) in West Bank and Gaza?
Make the answer very short. 2.13e+1. In the year 2007, what is the difference between the Exports (in Local Currency Unit) of St. Vincent and the Grenadines and Exports (in Local Currency Unit) of West Bank and Gaza?
Your answer should be very brief. -3.81e+09. In the year 2008, what is the difference between the Exports (in Local Currency Unit) of Afghanistan and Exports (in Local Currency Unit) of Comoros?
Your answer should be compact. 6.88e+1. In the year 2008, what is the difference between the Exports (in Local Currency Unit) of Afghanistan and Exports (in Local Currency Unit) of St. Vincent and the Grenadines?
Give a very brief answer. 9.28e+1. In the year 2008, what is the difference between the Exports (in Local Currency Unit) of Afghanistan and Exports (in Local Currency Unit) of West Bank and Gaza?
Offer a terse response. 8.93e+1. In the year 2008, what is the difference between the Exports (in Local Currency Unit) in Comoros and Exports (in Local Currency Unit) in St. Vincent and the Grenadines?
Make the answer very short. 2.41e+1. In the year 2008, what is the difference between the Exports (in Local Currency Unit) in Comoros and Exports (in Local Currency Unit) in West Bank and Gaza?
Your answer should be compact. 2.05e+1. In the year 2008, what is the difference between the Exports (in Local Currency Unit) of St. Vincent and the Grenadines and Exports (in Local Currency Unit) of West Bank and Gaza?
Offer a terse response. -3.56e+09. In the year 2009, what is the difference between the Exports (in Local Currency Unit) of Afghanistan and Exports (in Local Currency Unit) of Comoros?
Ensure brevity in your answer.  6.43e+1. In the year 2009, what is the difference between the Exports (in Local Currency Unit) in Afghanistan and Exports (in Local Currency Unit) in St. Vincent and the Grenadines?
Your response must be concise. 8.99e+1. In the year 2009, what is the difference between the Exports (in Local Currency Unit) in Afghanistan and Exports (in Local Currency Unit) in West Bank and Gaza?
Keep it short and to the point. 8.60e+1. In the year 2009, what is the difference between the Exports (in Local Currency Unit) of Comoros and Exports (in Local Currency Unit) of St. Vincent and the Grenadines?
Provide a succinct answer. 2.56e+1. In the year 2009, what is the difference between the Exports (in Local Currency Unit) in Comoros and Exports (in Local Currency Unit) in West Bank and Gaza?
Provide a succinct answer. 2.17e+1. In the year 2009, what is the difference between the Exports (in Local Currency Unit) in St. Vincent and the Grenadines and Exports (in Local Currency Unit) in West Bank and Gaza?
Provide a succinct answer. -3.95e+09. In the year 2010, what is the difference between the Exports (in Local Currency Unit) in Afghanistan and Exports (in Local Currency Unit) in Comoros?
Provide a short and direct response. 4.07e+1. In the year 2010, what is the difference between the Exports (in Local Currency Unit) of Afghanistan and Exports (in Local Currency Unit) of St. Vincent and the Grenadines?
Give a very brief answer. 7.27e+1. In the year 2010, what is the difference between the Exports (in Local Currency Unit) of Afghanistan and Exports (in Local Currency Unit) of West Bank and Gaza?
Provide a succinct answer. 6.81e+1. In the year 2010, what is the difference between the Exports (in Local Currency Unit) of Comoros and Exports (in Local Currency Unit) of St. Vincent and the Grenadines?
Your answer should be very brief. 3.20e+1. In the year 2010, what is the difference between the Exports (in Local Currency Unit) in Comoros and Exports (in Local Currency Unit) in West Bank and Gaza?
Your answer should be very brief. 2.74e+1. In the year 2010, what is the difference between the Exports (in Local Currency Unit) in St. Vincent and the Grenadines and Exports (in Local Currency Unit) in West Bank and Gaza?
Ensure brevity in your answer.  -4.61e+09. In the year 2011, what is the difference between the Exports (in Local Currency Unit) of Afghanistan and Exports (in Local Currency Unit) of Comoros?
Ensure brevity in your answer.  1.73e+1. In the year 2011, what is the difference between the Exports (in Local Currency Unit) of Afghanistan and Exports (in Local Currency Unit) of St. Vincent and the Grenadines?
Your response must be concise. 5.18e+1. In the year 2011, what is the difference between the Exports (in Local Currency Unit) of Afghanistan and Exports (in Local Currency Unit) of West Bank and Gaza?
Give a very brief answer. 4.59e+1. In the year 2011, what is the difference between the Exports (in Local Currency Unit) of Comoros and Exports (in Local Currency Unit) of St. Vincent and the Grenadines?
Provide a short and direct response. 3.45e+1. In the year 2011, what is the difference between the Exports (in Local Currency Unit) in Comoros and Exports (in Local Currency Unit) in West Bank and Gaza?
Give a very brief answer. 2.86e+1. In the year 2011, what is the difference between the Exports (in Local Currency Unit) of St. Vincent and the Grenadines and Exports (in Local Currency Unit) of West Bank and Gaza?
Make the answer very short. -5.95e+09. What is the ratio of the Exports (in Local Currency Unit) in Afghanistan in 2005 to that in 2006?
Offer a very short reply. 0.91. What is the ratio of the Exports (in Local Currency Unit) in Comoros in 2005 to that in 2006?
Your answer should be very brief. 0.96. What is the ratio of the Exports (in Local Currency Unit) in St. Vincent and the Grenadines in 2005 to that in 2006?
Provide a succinct answer. 0.95. What is the ratio of the Exports (in Local Currency Unit) in Afghanistan in 2005 to that in 2007?
Keep it short and to the point. 0.98. What is the ratio of the Exports (in Local Currency Unit) in Comoros in 2005 to that in 2007?
Your answer should be compact. 0.88. What is the ratio of the Exports (in Local Currency Unit) of St. Vincent and the Grenadines in 2005 to that in 2007?
Ensure brevity in your answer.  0.94. What is the ratio of the Exports (in Local Currency Unit) in West Bank and Gaza in 2005 to that in 2007?
Your answer should be compact. 0.74. What is the ratio of the Exports (in Local Currency Unit) of Afghanistan in 2005 to that in 2008?
Your response must be concise. 0.91. What is the ratio of the Exports (in Local Currency Unit) of Comoros in 2005 to that in 2008?
Offer a very short reply. 0.92. What is the ratio of the Exports (in Local Currency Unit) in St. Vincent and the Grenadines in 2005 to that in 2008?
Give a very brief answer. 0.95. What is the ratio of the Exports (in Local Currency Unit) of West Bank and Gaza in 2005 to that in 2008?
Your answer should be compact. 0.79. What is the ratio of the Exports (in Local Currency Unit) of Afghanistan in 2005 to that in 2009?
Your answer should be compact. 0.94. What is the ratio of the Exports (in Local Currency Unit) in Comoros in 2005 to that in 2009?
Your answer should be very brief. 0.86. What is the ratio of the Exports (in Local Currency Unit) in St. Vincent and the Grenadines in 2005 to that in 2009?
Your answer should be compact. 1.04. What is the ratio of the Exports (in Local Currency Unit) in West Bank and Gaza in 2005 to that in 2009?
Keep it short and to the point. 0.73. What is the ratio of the Exports (in Local Currency Unit) of Afghanistan in 2005 to that in 2010?
Ensure brevity in your answer.  1.17. What is the ratio of the Exports (in Local Currency Unit) of Comoros in 2005 to that in 2010?
Provide a succinct answer. 0.7. What is the ratio of the Exports (in Local Currency Unit) of St. Vincent and the Grenadines in 2005 to that in 2010?
Your response must be concise. 1.09. What is the ratio of the Exports (in Local Currency Unit) of West Bank and Gaza in 2005 to that in 2010?
Provide a succinct answer. 0.64. What is the ratio of the Exports (in Local Currency Unit) of Afghanistan in 2005 to that in 2011?
Your answer should be very brief. 1.63. What is the ratio of the Exports (in Local Currency Unit) in Comoros in 2005 to that in 2011?
Your response must be concise. 0.65. What is the ratio of the Exports (in Local Currency Unit) of St. Vincent and the Grenadines in 2005 to that in 2011?
Provide a succinct answer. 1.1. What is the ratio of the Exports (in Local Currency Unit) in West Bank and Gaza in 2005 to that in 2011?
Provide a succinct answer. 0.5. What is the ratio of the Exports (in Local Currency Unit) in Afghanistan in 2006 to that in 2007?
Your answer should be very brief. 1.07. What is the ratio of the Exports (in Local Currency Unit) in Comoros in 2006 to that in 2007?
Offer a terse response. 0.92. What is the ratio of the Exports (in Local Currency Unit) in St. Vincent and the Grenadines in 2006 to that in 2007?
Your answer should be very brief. 1. What is the ratio of the Exports (in Local Currency Unit) in West Bank and Gaza in 2006 to that in 2007?
Offer a terse response. 0.75. What is the ratio of the Exports (in Local Currency Unit) in Afghanistan in 2006 to that in 2008?
Ensure brevity in your answer.  1. What is the ratio of the Exports (in Local Currency Unit) in Comoros in 2006 to that in 2008?
Provide a short and direct response. 0.96. What is the ratio of the Exports (in Local Currency Unit) in St. Vincent and the Grenadines in 2006 to that in 2008?
Provide a short and direct response. 1.01. What is the ratio of the Exports (in Local Currency Unit) in West Bank and Gaza in 2006 to that in 2008?
Your response must be concise. 0.8. What is the ratio of the Exports (in Local Currency Unit) in Afghanistan in 2006 to that in 2009?
Offer a terse response. 1.03. What is the ratio of the Exports (in Local Currency Unit) of Comoros in 2006 to that in 2009?
Provide a short and direct response. 0.9. What is the ratio of the Exports (in Local Currency Unit) of St. Vincent and the Grenadines in 2006 to that in 2009?
Give a very brief answer. 1.1. What is the ratio of the Exports (in Local Currency Unit) of West Bank and Gaza in 2006 to that in 2009?
Your answer should be compact. 0.74. What is the ratio of the Exports (in Local Currency Unit) of Afghanistan in 2006 to that in 2010?
Ensure brevity in your answer.  1.27. What is the ratio of the Exports (in Local Currency Unit) of Comoros in 2006 to that in 2010?
Make the answer very short. 0.73. What is the ratio of the Exports (in Local Currency Unit) in St. Vincent and the Grenadines in 2006 to that in 2010?
Offer a terse response. 1.16. What is the ratio of the Exports (in Local Currency Unit) in West Bank and Gaza in 2006 to that in 2010?
Offer a terse response. 0.64. What is the ratio of the Exports (in Local Currency Unit) in Afghanistan in 2006 to that in 2011?
Your answer should be compact. 1.78. What is the ratio of the Exports (in Local Currency Unit) of Comoros in 2006 to that in 2011?
Ensure brevity in your answer.  0.67. What is the ratio of the Exports (in Local Currency Unit) of St. Vincent and the Grenadines in 2006 to that in 2011?
Your answer should be very brief. 1.16. What is the ratio of the Exports (in Local Currency Unit) of West Bank and Gaza in 2006 to that in 2011?
Provide a short and direct response. 0.51. What is the ratio of the Exports (in Local Currency Unit) of Afghanistan in 2007 to that in 2008?
Your response must be concise. 0.94. What is the ratio of the Exports (in Local Currency Unit) in Comoros in 2007 to that in 2008?
Offer a terse response. 1.04. What is the ratio of the Exports (in Local Currency Unit) in St. Vincent and the Grenadines in 2007 to that in 2008?
Provide a short and direct response. 1.01. What is the ratio of the Exports (in Local Currency Unit) of West Bank and Gaza in 2007 to that in 2008?
Your answer should be compact. 1.06. What is the ratio of the Exports (in Local Currency Unit) in Afghanistan in 2007 to that in 2009?
Keep it short and to the point. 0.97. What is the ratio of the Exports (in Local Currency Unit) in Comoros in 2007 to that in 2009?
Offer a terse response. 0.98. What is the ratio of the Exports (in Local Currency Unit) of St. Vincent and the Grenadines in 2007 to that in 2009?
Ensure brevity in your answer.  1.1. What is the ratio of the Exports (in Local Currency Unit) in West Bank and Gaza in 2007 to that in 2009?
Ensure brevity in your answer.  0.98. What is the ratio of the Exports (in Local Currency Unit) of Afghanistan in 2007 to that in 2010?
Provide a short and direct response. 1.19. What is the ratio of the Exports (in Local Currency Unit) in Comoros in 2007 to that in 2010?
Ensure brevity in your answer.  0.79. What is the ratio of the Exports (in Local Currency Unit) of St. Vincent and the Grenadines in 2007 to that in 2010?
Give a very brief answer. 1.16. What is the ratio of the Exports (in Local Currency Unit) of West Bank and Gaza in 2007 to that in 2010?
Offer a very short reply. 0.86. What is the ratio of the Exports (in Local Currency Unit) of Afghanistan in 2007 to that in 2011?
Keep it short and to the point. 1.67. What is the ratio of the Exports (in Local Currency Unit) in Comoros in 2007 to that in 2011?
Ensure brevity in your answer.  0.73. What is the ratio of the Exports (in Local Currency Unit) in St. Vincent and the Grenadines in 2007 to that in 2011?
Provide a succinct answer. 1.16. What is the ratio of the Exports (in Local Currency Unit) of West Bank and Gaza in 2007 to that in 2011?
Make the answer very short. 0.68. What is the ratio of the Exports (in Local Currency Unit) in Afghanistan in 2008 to that in 2009?
Provide a succinct answer. 1.03. What is the ratio of the Exports (in Local Currency Unit) in Comoros in 2008 to that in 2009?
Keep it short and to the point. 0.94. What is the ratio of the Exports (in Local Currency Unit) in St. Vincent and the Grenadines in 2008 to that in 2009?
Offer a very short reply. 1.09. What is the ratio of the Exports (in Local Currency Unit) of West Bank and Gaza in 2008 to that in 2009?
Your answer should be compact. 0.92. What is the ratio of the Exports (in Local Currency Unit) in Afghanistan in 2008 to that in 2010?
Offer a terse response. 1.28. What is the ratio of the Exports (in Local Currency Unit) in Comoros in 2008 to that in 2010?
Offer a very short reply. 0.76. What is the ratio of the Exports (in Local Currency Unit) in St. Vincent and the Grenadines in 2008 to that in 2010?
Make the answer very short. 1.15. What is the ratio of the Exports (in Local Currency Unit) in West Bank and Gaza in 2008 to that in 2010?
Keep it short and to the point. 0.81. What is the ratio of the Exports (in Local Currency Unit) in Afghanistan in 2008 to that in 2011?
Your answer should be compact. 1.79. What is the ratio of the Exports (in Local Currency Unit) in Comoros in 2008 to that in 2011?
Keep it short and to the point. 0.7. What is the ratio of the Exports (in Local Currency Unit) in St. Vincent and the Grenadines in 2008 to that in 2011?
Keep it short and to the point. 1.15. What is the ratio of the Exports (in Local Currency Unit) of West Bank and Gaza in 2008 to that in 2011?
Make the answer very short. 0.64. What is the ratio of the Exports (in Local Currency Unit) in Afghanistan in 2009 to that in 2010?
Keep it short and to the point. 1.24. What is the ratio of the Exports (in Local Currency Unit) of Comoros in 2009 to that in 2010?
Provide a short and direct response. 0.81. What is the ratio of the Exports (in Local Currency Unit) in St. Vincent and the Grenadines in 2009 to that in 2010?
Offer a terse response. 1.05. What is the ratio of the Exports (in Local Currency Unit) of West Bank and Gaza in 2009 to that in 2010?
Your answer should be very brief. 0.88. What is the ratio of the Exports (in Local Currency Unit) in Afghanistan in 2009 to that in 2011?
Ensure brevity in your answer.  1.73. What is the ratio of the Exports (in Local Currency Unit) of Comoros in 2009 to that in 2011?
Keep it short and to the point. 0.75. What is the ratio of the Exports (in Local Currency Unit) in St. Vincent and the Grenadines in 2009 to that in 2011?
Provide a succinct answer. 1.05. What is the ratio of the Exports (in Local Currency Unit) in West Bank and Gaza in 2009 to that in 2011?
Your response must be concise. 0.69. What is the ratio of the Exports (in Local Currency Unit) in Afghanistan in 2010 to that in 2011?
Offer a very short reply. 1.4. What is the ratio of the Exports (in Local Currency Unit) of Comoros in 2010 to that in 2011?
Give a very brief answer. 0.93. What is the ratio of the Exports (in Local Currency Unit) in St. Vincent and the Grenadines in 2010 to that in 2011?
Give a very brief answer. 1. What is the ratio of the Exports (in Local Currency Unit) of West Bank and Gaza in 2010 to that in 2011?
Provide a short and direct response. 0.79. What is the difference between the highest and the second highest Exports (in Local Currency Unit) in Afghanistan?
Make the answer very short. 1.60e+08. What is the difference between the highest and the second highest Exports (in Local Currency Unit) of Comoros?
Provide a short and direct response. 2.54e+09. What is the difference between the highest and the second highest Exports (in Local Currency Unit) in St. Vincent and the Grenadines?
Give a very brief answer. 6.09e+05. What is the difference between the highest and the second highest Exports (in Local Currency Unit) in West Bank and Gaza?
Your answer should be very brief. 1.34e+09. What is the difference between the highest and the lowest Exports (in Local Currency Unit) in Afghanistan?
Ensure brevity in your answer.  4.11e+1. What is the difference between the highest and the lowest Exports (in Local Currency Unit) of Comoros?
Give a very brief answer. 1.24e+1. What is the difference between the highest and the lowest Exports (in Local Currency Unit) of St. Vincent and the Grenadines?
Ensure brevity in your answer.  7.95e+07. What is the difference between the highest and the lowest Exports (in Local Currency Unit) of West Bank and Gaza?
Make the answer very short. 3.19e+09. 